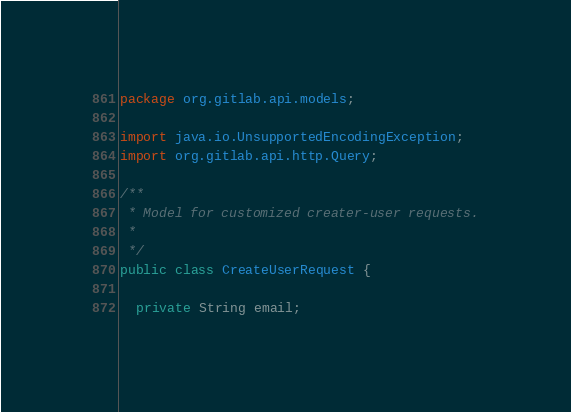Convert code to text. <code><loc_0><loc_0><loc_500><loc_500><_Java_>package org.gitlab.api.models;

import java.io.UnsupportedEncodingException;
import org.gitlab.api.http.Query;

/**
 * Model for customized creater-user requests.
 *
 */
public class CreateUserRequest {

  private String email;</code> 